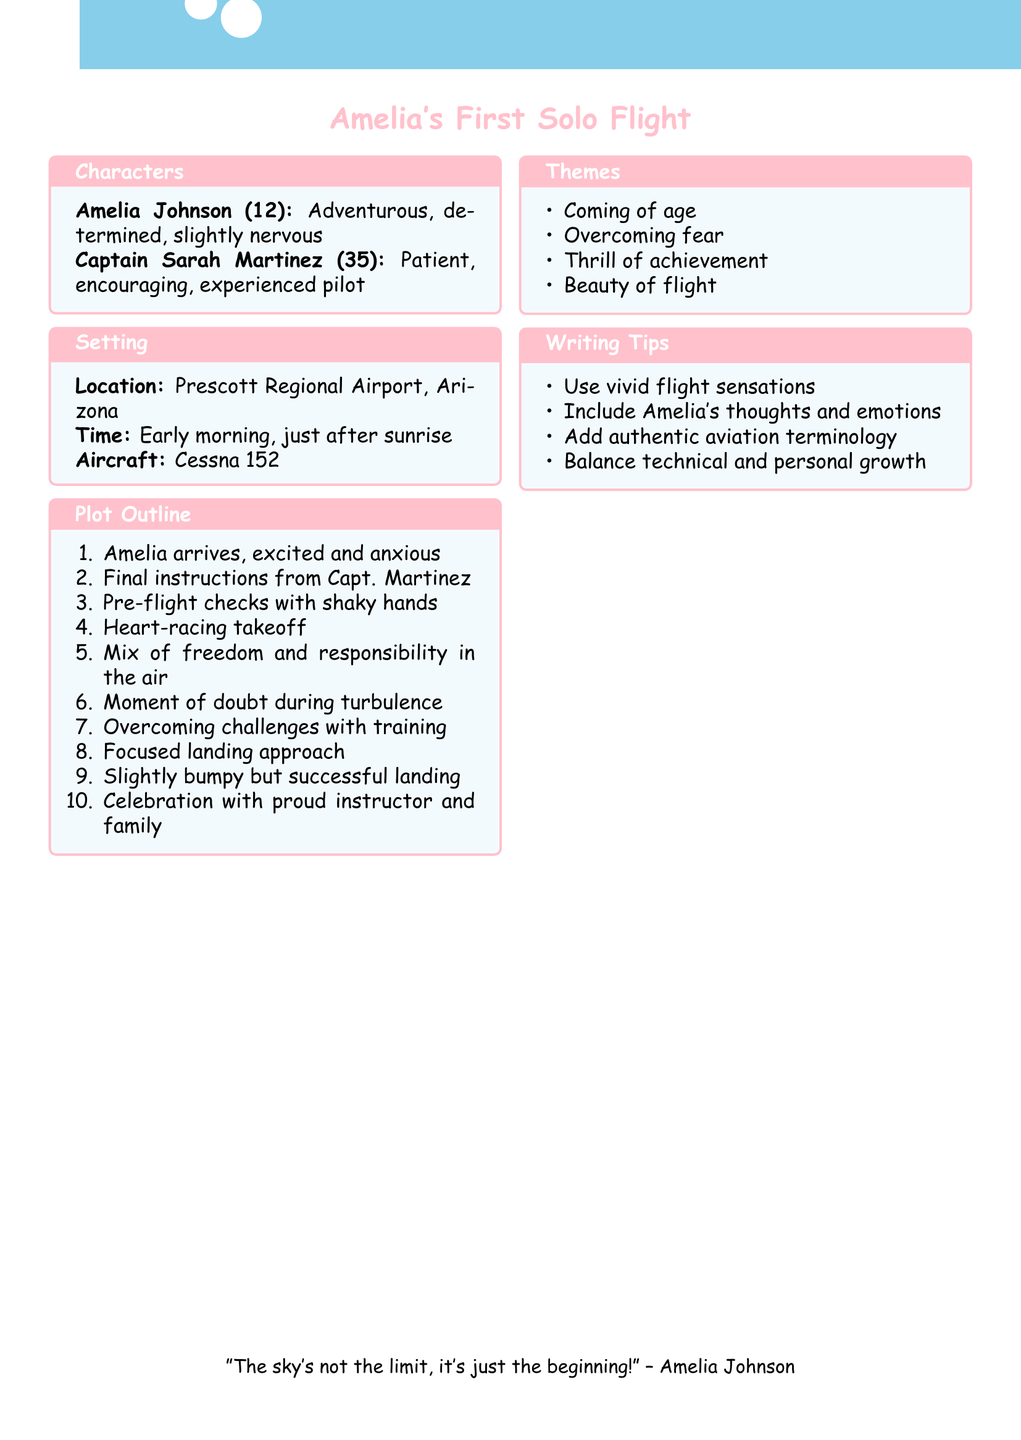What is the name of the main character? The main character is described in the document under character descriptions, specifically as Amelia Johnson.
Answer: Amelia Johnson How old is Amelia? The character descriptions provide Amelia's age as part of the information, which is explicitly stated.
Answer: 12 What is the aircraft type mentioned in the setting? The setting section of the document clearly states the type of aircraft used in the story.
Answer: Cessna 152 What is the primary theme of the story? The themes section lists several themes, and one is explicitly noted as the primary focus of the story.
Answer: Coming of age Who is Amelia's flight instructor? The character descriptions section identifies Amelia's flight instructor by name and traits.
Answer: Captain Sarah Martinez What time of day does the story take place? The setting details the time for the story, which is highlighted in the setting box.
Answer: Early morning What does Amelia experience during her first solo flight? The plot outline indicates a mixture of feelings during Amelia's flight, prompting a deeper understanding of her journey.
Answer: Freedom and responsibility What challenges does Amelia face during her flight? A specific moment is mentioned in the plot outline, requiring synthesis of information regarding Amelia's experience.
Answer: Mild turbulence What writing tip emphasizes Amelia's emotional journey? The writing tips provide guidance on how to convey Amelia's experiences, indicating a focus on her inner thoughts.
Answer: Include Amelia's thoughts and emotions 